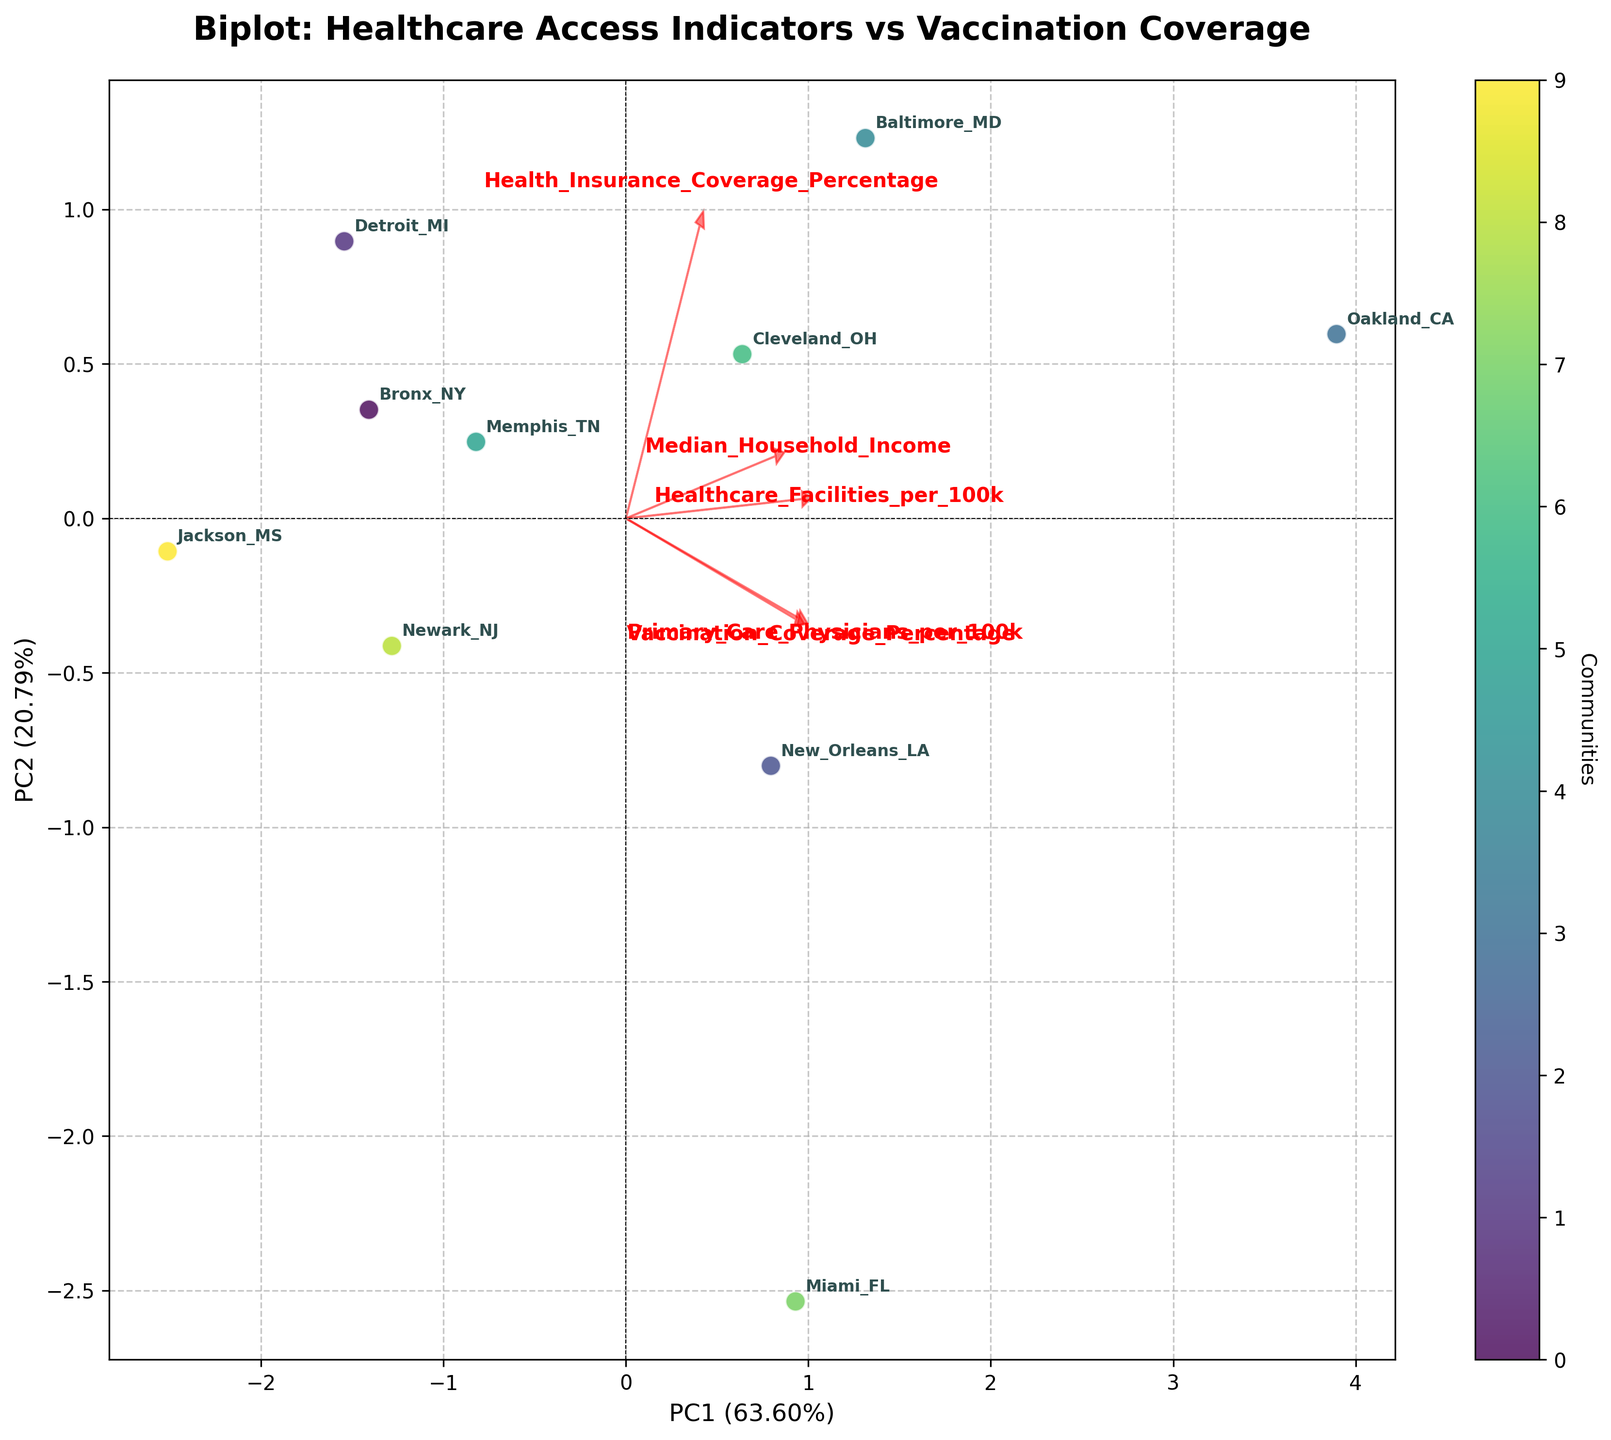How many communities are represented in the biplot? By counting the number of points in the figure, each annotated with a community name, we can see there are 10 communities in the biplot.
Answer: 10 What does PC1 represent in terms of variance explained? The x-axis label in the biplot shows that PC1 accounts for a specific percentage of the data's variance. According to the label, PC1 represents 43.2% of the variance explained.
Answer: 43.2% Which community has the highest score on PC2? By examining the positions of all communities along the y-axis (PC2) and identifying the one that is furthest above the zero line, we see that Detroit_MI has the highest score on PC2.
Answer: Detroit_MI Between New_Orleans_LA and Oakland_CA, which community has a higher value on PC1? By comparing the x-axis (PC1) coordinates of New_Orleans_LA and Oakland_CA, Oakland_CA is placed further to the right, indicating it has a higher PC1 value.
Answer: Oakland_CA What are the variables represented by the vectors pointing to the right? In the biplot, the vectors that point to the right side include the Healthcare_Facilities_per_100k, Median_Household_Income, and Health_Insurance_Coverage_Percentage variables as shown in the arrows' direction and accompanying labels.
Answer: Healthcare_Facilities_per_100k, Median_Household_Income, Health_Insurance_Coverage_Percentage Which variable is most strongly associated with PC1? By observing which vector is the longest and most aligned with the direction of the x-axis (PC1), we find that the vector for Median_Household_Income aligns closely with PC1.
Answer: Median_Household_Income Describe the association between Primary_Care_Physicians_per_100k and Vaccination_Coverage_Percentage. By looking at the vectors for Primary_Care_Physicians_per_100k and Vaccination_Coverage_Percentage, they both point in nearly the same upward direction, indicating a positive association between these two variables.
Answer: Positive association Which variables appear to be positively correlated based on the biplot vectors? Positive correlations among variables are indicated by vectors pointing in similar directions. Here, Primary_Care_Physicians_per_100k, Vaccination_Coverage_Percentage, and Healthcare_Facilities_per_100k show this trend.
Answer: Primary_Care_Physicians_per_100k and Vaccination_Coverage_Percentage, Healthcare_Facilities_per_100k How does Baltimore_MD's position reflect its healthcare and socio-economic indicators? Baltimore_MD's position near the center indicates moderate levels of the indicators relative to the other communities. It neither lies far along PC1 nor PC2, suggesting average socio-economic and healthcare access indicators.
Answer: Moderate levels 